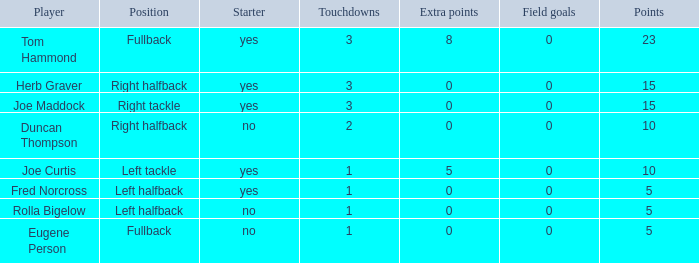What is the mean number of field goals for a right halfback who has achieved over 3 touchdowns? None. Could you parse the entire table as a dict? {'header': ['Player', 'Position', 'Starter', 'Touchdowns', 'Extra points', 'Field goals', 'Points'], 'rows': [['Tom Hammond', 'Fullback', 'yes', '3', '8', '0', '23'], ['Herb Graver', 'Right halfback', 'yes', '3', '0', '0', '15'], ['Joe Maddock', 'Right tackle', 'yes', '3', '0', '0', '15'], ['Duncan Thompson', 'Right halfback', 'no', '2', '0', '0', '10'], ['Joe Curtis', 'Left tackle', 'yes', '1', '5', '0', '10'], ['Fred Norcross', 'Left halfback', 'yes', '1', '0', '0', '5'], ['Rolla Bigelow', 'Left halfback', 'no', '1', '0', '0', '5'], ['Eugene Person', 'Fullback', 'no', '1', '0', '0', '5']]} 